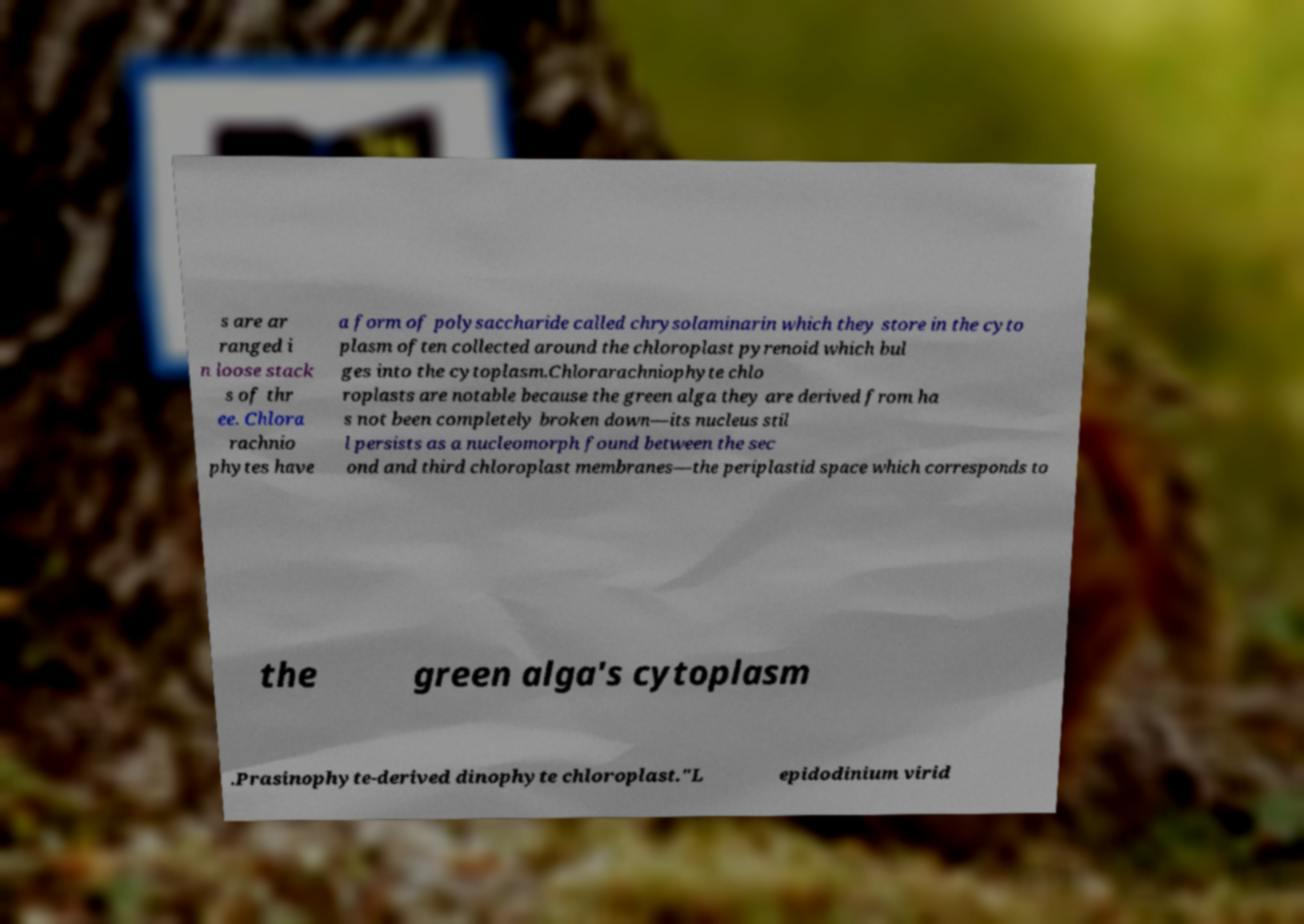Can you accurately transcribe the text from the provided image for me? s are ar ranged i n loose stack s of thr ee. Chlora rachnio phytes have a form of polysaccharide called chrysolaminarin which they store in the cyto plasm often collected around the chloroplast pyrenoid which bul ges into the cytoplasm.Chlorarachniophyte chlo roplasts are notable because the green alga they are derived from ha s not been completely broken down—its nucleus stil l persists as a nucleomorph found between the sec ond and third chloroplast membranes—the periplastid space which corresponds to the green alga's cytoplasm .Prasinophyte-derived dinophyte chloroplast."L epidodinium virid 